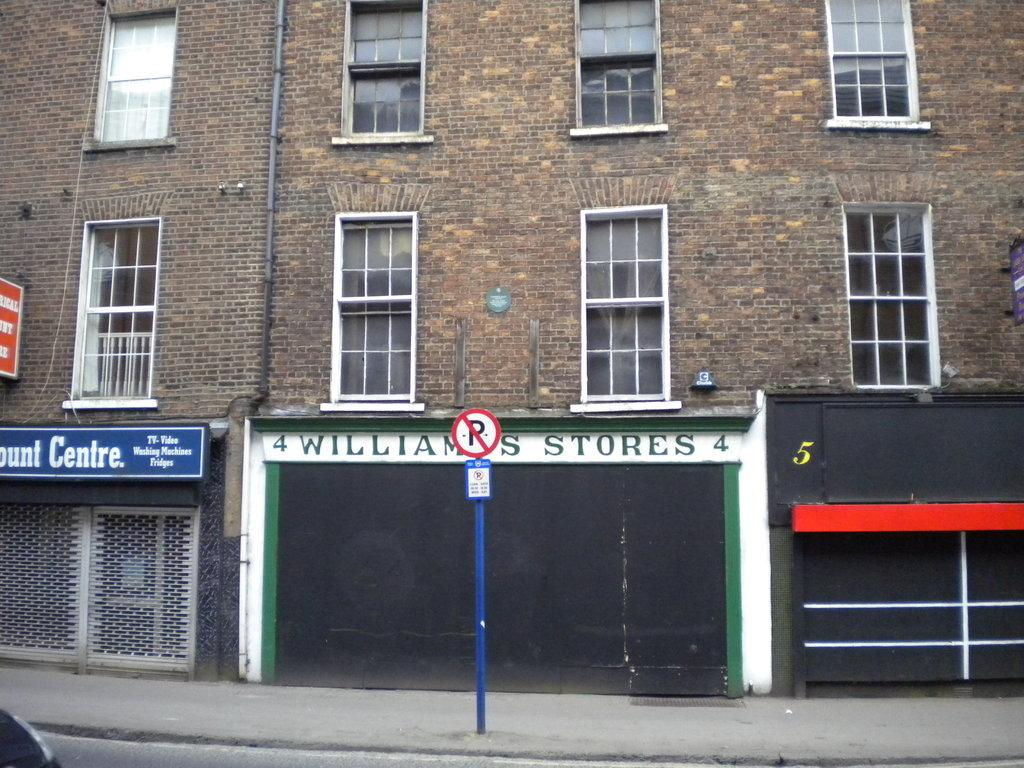What type of structure is visible in the image? There is a building in the image. What feature can be seen on the building? The building has windows. What other objects are present in the image? There is a pipe and a pole in the image. Are there any additional items visible on the building or nearby? Yes, there are posters in the image. How much dirt is visible on the pan in the image? There is no pan present in the image, so it is impossible to determine the amount of dirt on it. 